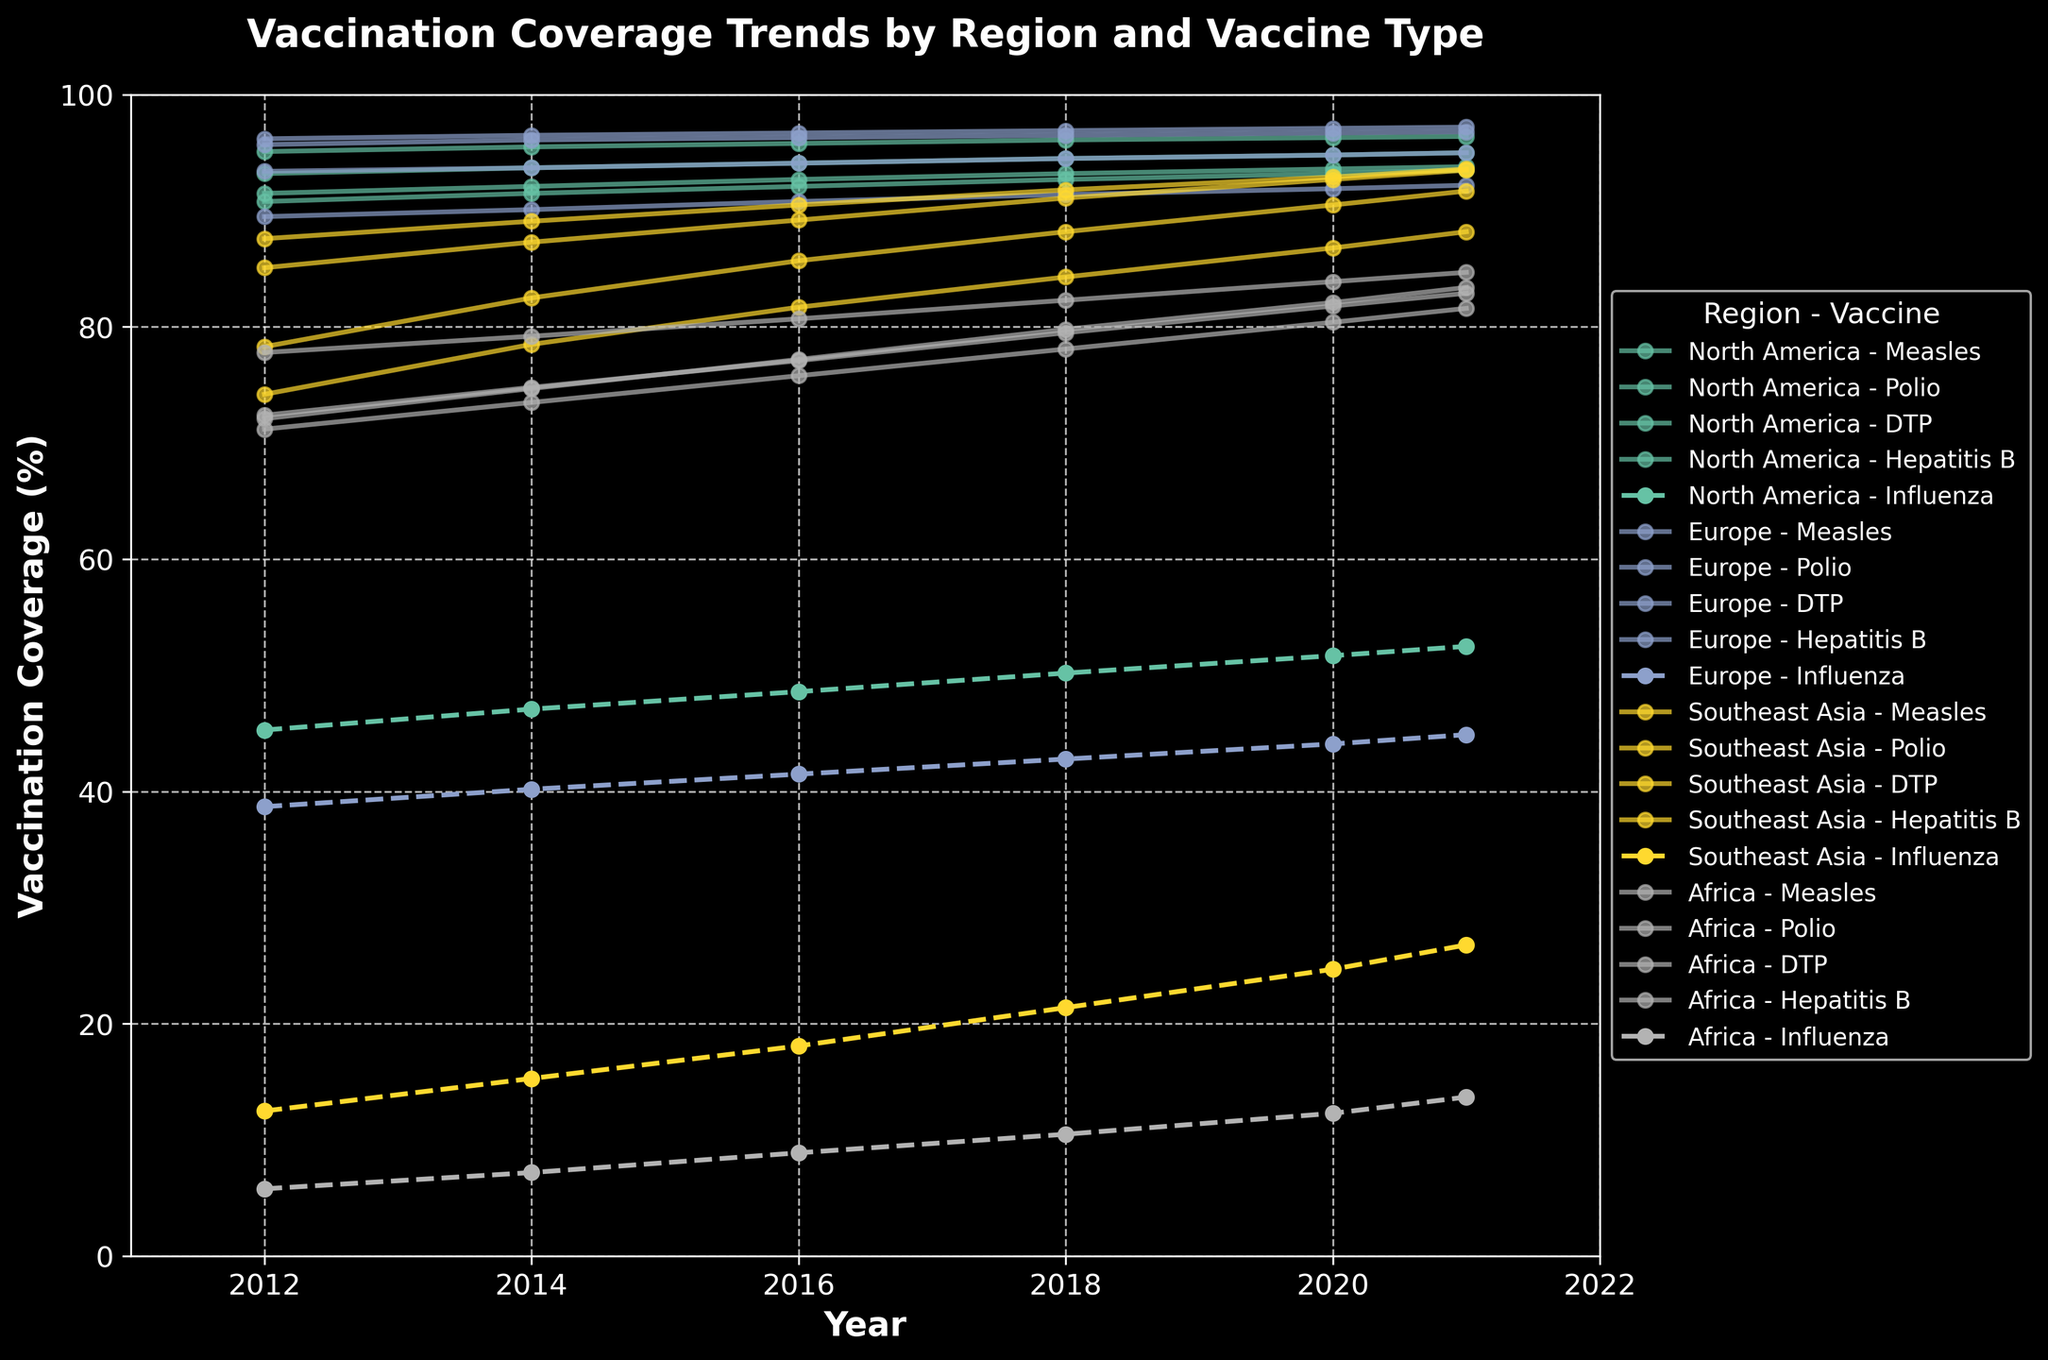What is the trend of measles vaccination coverage in North America from 2012 to 2021? The measles vaccination coverage in North America increased from 91.5% in 2012 to 93.8% in 2021. This increase can be observed by following the measles line marked for North America, which consistently rises over the period.
Answer: It increased from 91.5% to 93.8% In what year did Europe achieve the highest coverage for DTP vaccination? By observing the DTP lines for Europe, the highest coverage is seen at the year 2021 where the value is at its peak compared to other years.
Answer: 2021 Which vaccine has the lowest coverage in Southeast Asia in 2016? By comparing the coverage for all vaccines in Southeast Asia in 2016, it is evident that Influenza has the lowest coverage value in that year.
Answer: Influenza How does the hepatitis B vaccination coverage in Africa in 2021 compare to that in 2012? Comparing the hepatitis B values for Africa in 2021 and 2012, the coverage increased from 72.1% in 2012 to 83.4% in 2021.
Answer: Increased from 72.1% to 83.4% What is the difference in polio vaccination coverage between South East Asia and North America in 2018? The polio coverage in South East Asia in 2018 was 91.1% and in North America, it was 94.5%. The difference can be calculated by subtracting 91.1 from 94.5, which gives 3.4%.
Answer: 3.4% How does the color of the line representing influenza vaccination coverage generally differ from the other vaccines? The influenza vaccination coverage lines are distinguishable by a dashed linestyle, whereas the other vaccines are represented by solid lines. This visual distinction helps to easily identify the influenza vaccination trend.
Answer: Dashed linestyles What is the trend of influenza vaccination coverage in Africa from 2012 to 2021? The influenza vaccination coverage in Africa shows a steady increase from 5.8% in 2012 to 13.7% in 2021, as the line slopes upward over the years in the region's graph.
Answer: Increased from 5.8% to 13.7% Which region shows the largest increase in DTP vaccination coverage from 2012 to 2021? Observing each region's DTP coverage from 2012 to 2021, Southeast Asia shows a significant rise from 87.6% to 93.6% which is a 6.0% increase, the largest compared to other regions.
Answer: Southeast Asia By how much did the measles vaccination coverage in Europe increase from 2012 to 2016? The measles vaccination coverage in Europe can be tracked from 93.4% in 2012 to 94.1% in 2016. The difference is found by subtracting 93.4 from 94.1, which equals 0.7%.
Answer: 0.7% 